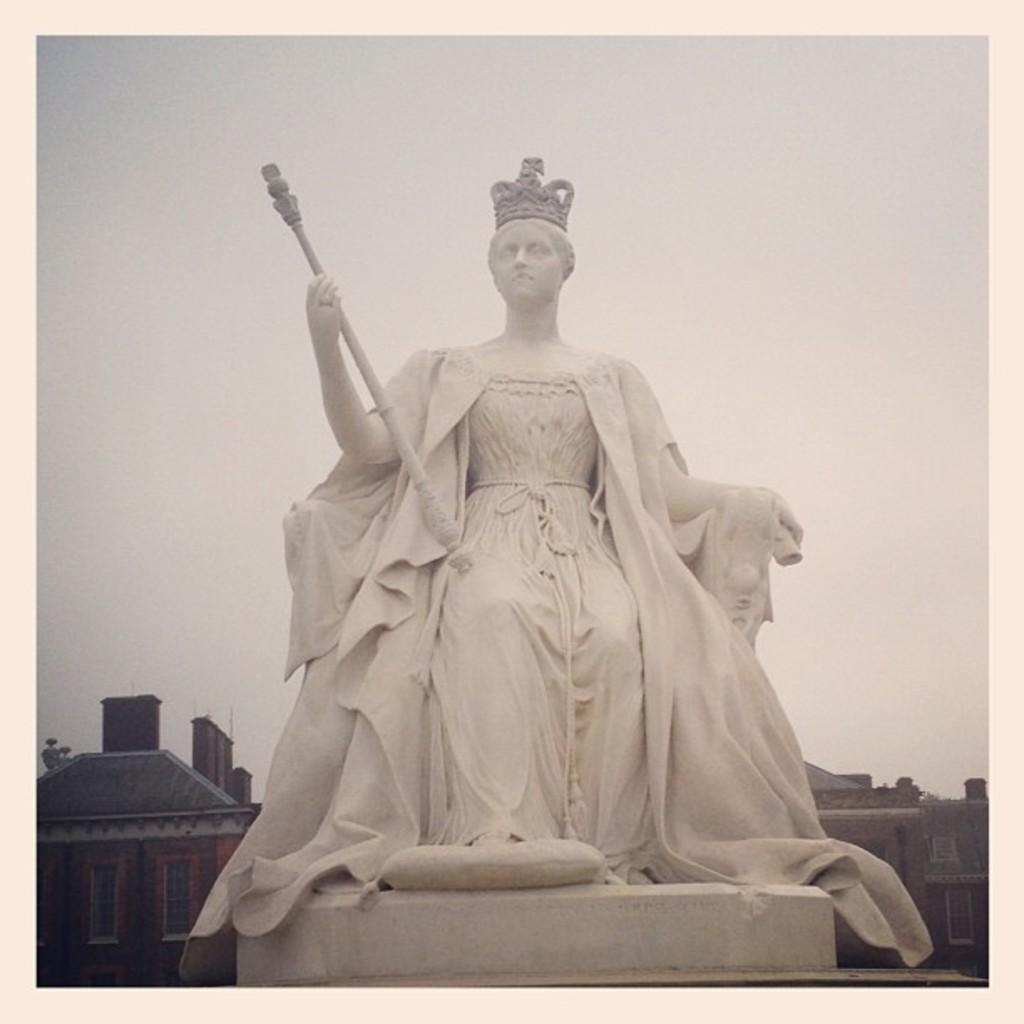Can you describe this image briefly? In the background we can see the sky, buildings, windows. In this picture we can see the statue of a woman, holding an object which is placed on the pedestal. 